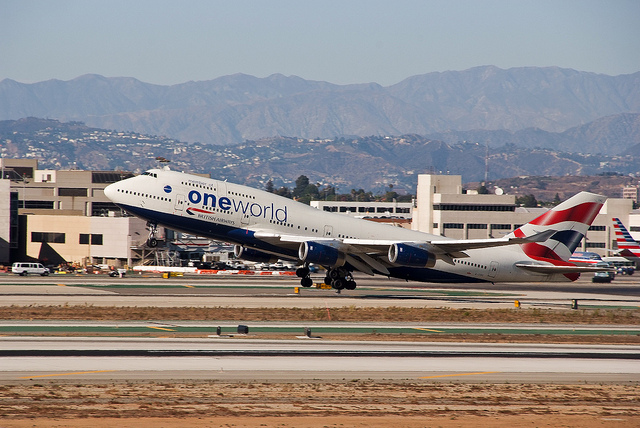Please extract the text content from this image. oneworld 